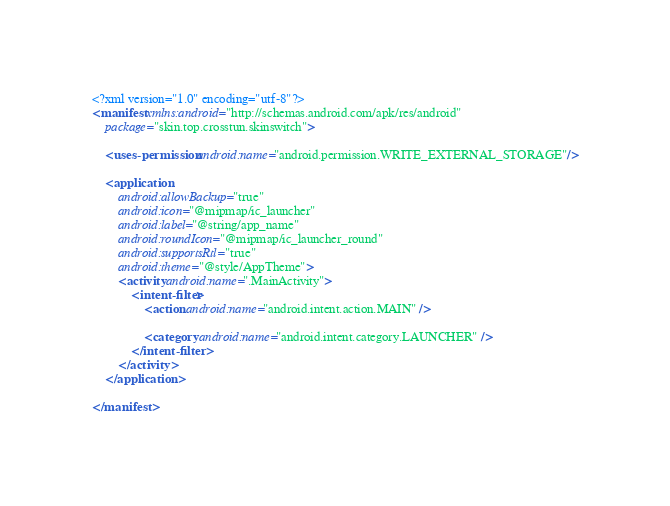Convert code to text. <code><loc_0><loc_0><loc_500><loc_500><_XML_><?xml version="1.0" encoding="utf-8"?>
<manifest xmlns:android="http://schemas.android.com/apk/res/android"
    package="skin.top.crosstun.skinswitch">

    <uses-permission android:name="android.permission.WRITE_EXTERNAL_STORAGE"/>

    <application
        android:allowBackup="true"
        android:icon="@mipmap/ic_launcher"
        android:label="@string/app_name"
        android:roundIcon="@mipmap/ic_launcher_round"
        android:supportsRtl="true"
        android:theme="@style/AppTheme">
        <activity android:name=".MainActivity">
            <intent-filter>
                <action android:name="android.intent.action.MAIN" />

                <category android:name="android.intent.category.LAUNCHER" />
            </intent-filter>
        </activity>
    </application>

</manifest></code> 